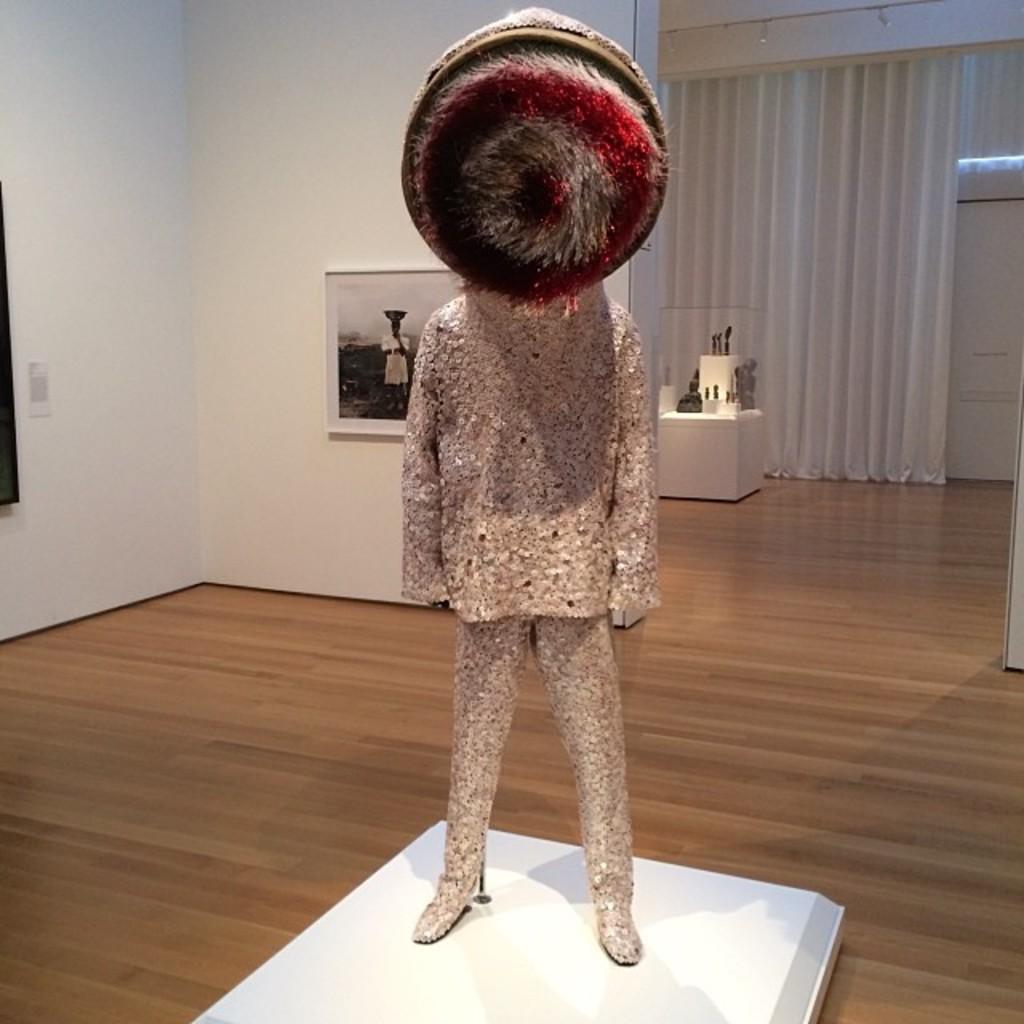In one or two sentences, can you explain what this image depicts? In this picture we can see sculpture is placed in a room, behind we can see frame to the wall and we can see few objects. 